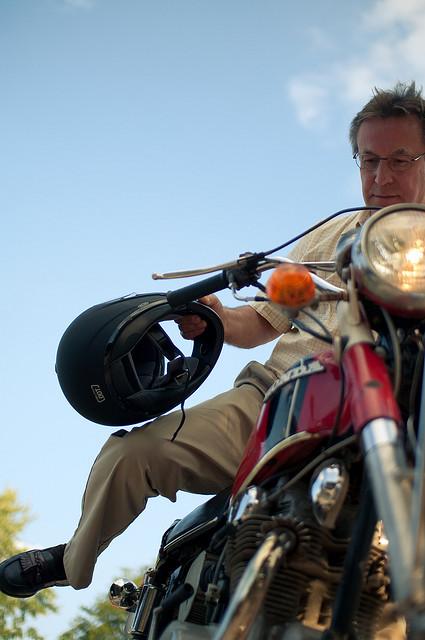Is this person violating a law?
Concise answer only. No. Is this person wearing a uniform?
Be succinct. Yes. What is the  person doing on the motorcycle?
Short answer required. Getting on. 